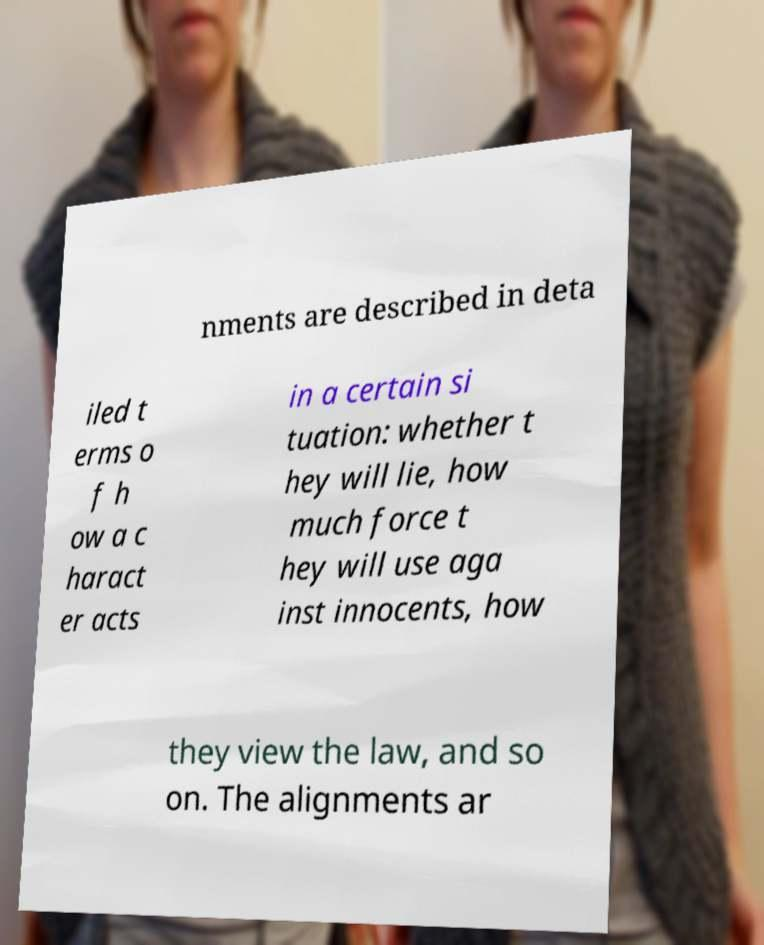For documentation purposes, I need the text within this image transcribed. Could you provide that? nments are described in deta iled t erms o f h ow a c haract er acts in a certain si tuation: whether t hey will lie, how much force t hey will use aga inst innocents, how they view the law, and so on. The alignments ar 